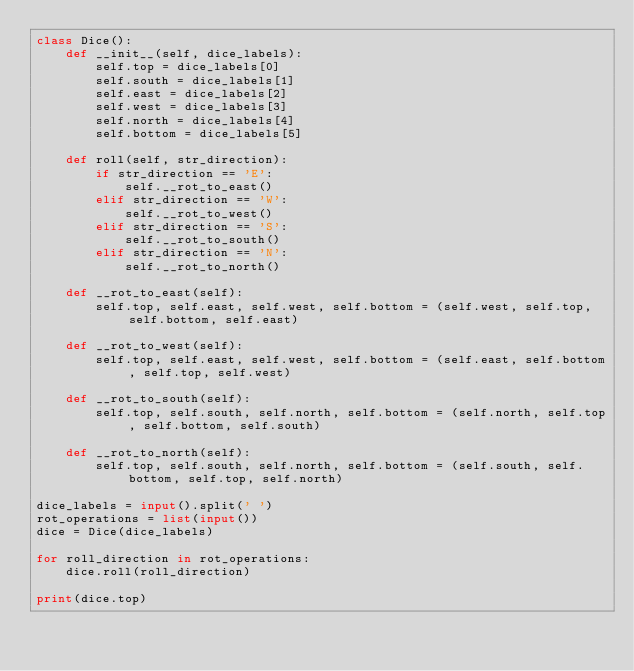<code> <loc_0><loc_0><loc_500><loc_500><_Python_>class Dice():
    def __init__(self, dice_labels):
        self.top = dice_labels[0]
        self.south = dice_labels[1]
        self.east = dice_labels[2]
        self.west = dice_labels[3]
        self.north = dice_labels[4]
        self.bottom = dice_labels[5]

    def roll(self, str_direction):
        if str_direction == 'E':
            self.__rot_to_east()
        elif str_direction == 'W':
            self.__rot_to_west()
        elif str_direction == 'S':
            self.__rot_to_south()
        elif str_direction == 'N':
            self.__rot_to_north()

    def __rot_to_east(self):
        self.top, self.east, self.west, self.bottom = (self.west, self.top, self.bottom, self.east)

    def __rot_to_west(self):
        self.top, self.east, self.west, self.bottom = (self.east, self.bottom, self.top, self.west)

    def __rot_to_south(self):
        self.top, self.south, self.north, self.bottom = (self.north, self.top, self.bottom, self.south)

    def __rot_to_north(self):
        self.top, self.south, self.north, self.bottom = (self.south, self.bottom, self.top, self.north)

dice_labels = input().split(' ')
rot_operations = list(input())
dice = Dice(dice_labels)

for roll_direction in rot_operations:
    dice.roll(roll_direction)

print(dice.top)

</code> 